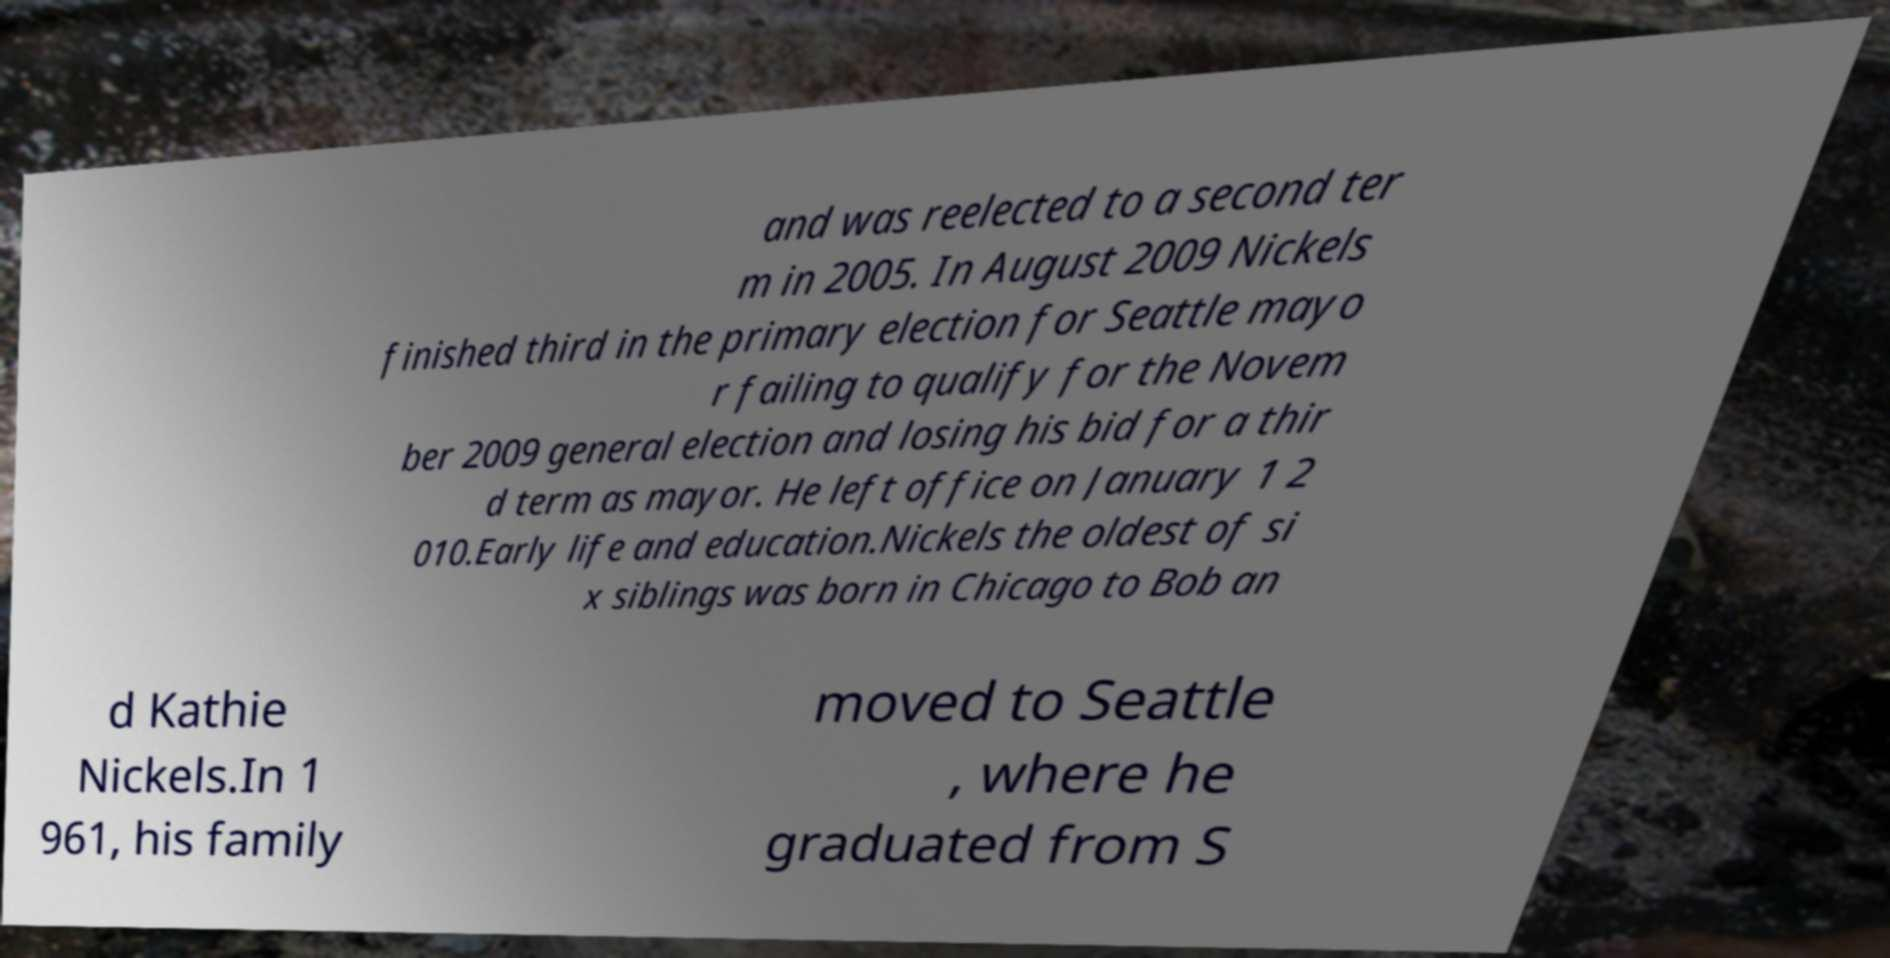Can you read and provide the text displayed in the image?This photo seems to have some interesting text. Can you extract and type it out for me? and was reelected to a second ter m in 2005. In August 2009 Nickels finished third in the primary election for Seattle mayo r failing to qualify for the Novem ber 2009 general election and losing his bid for a thir d term as mayor. He left office on January 1 2 010.Early life and education.Nickels the oldest of si x siblings was born in Chicago to Bob an d Kathie Nickels.In 1 961, his family moved to Seattle , where he graduated from S 